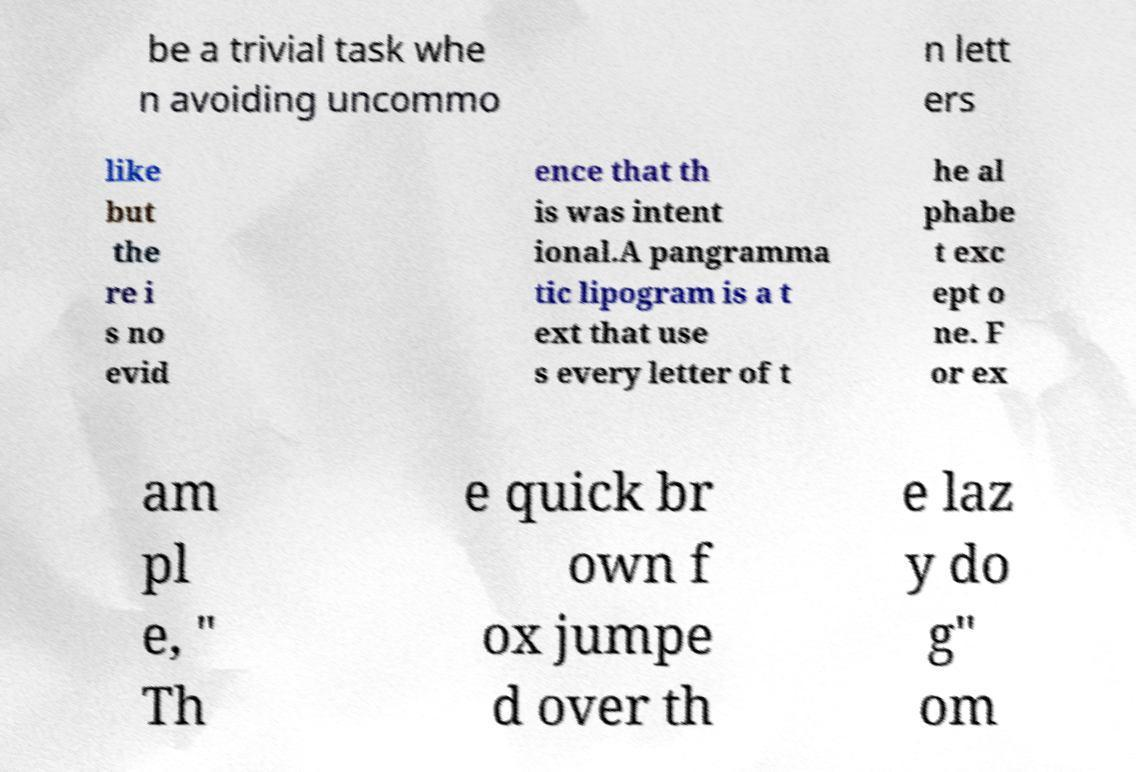There's text embedded in this image that I need extracted. Can you transcribe it verbatim? be a trivial task whe n avoiding uncommo n lett ers like but the re i s no evid ence that th is was intent ional.A pangramma tic lipogram is a t ext that use s every letter of t he al phabe t exc ept o ne. F or ex am pl e, " Th e quick br own f ox jumpe d over th e laz y do g" om 